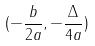Convert formula to latex. <formula><loc_0><loc_0><loc_500><loc_500>( - \frac { b } { 2 a } , - \frac { \Delta } { 4 a } )</formula> 